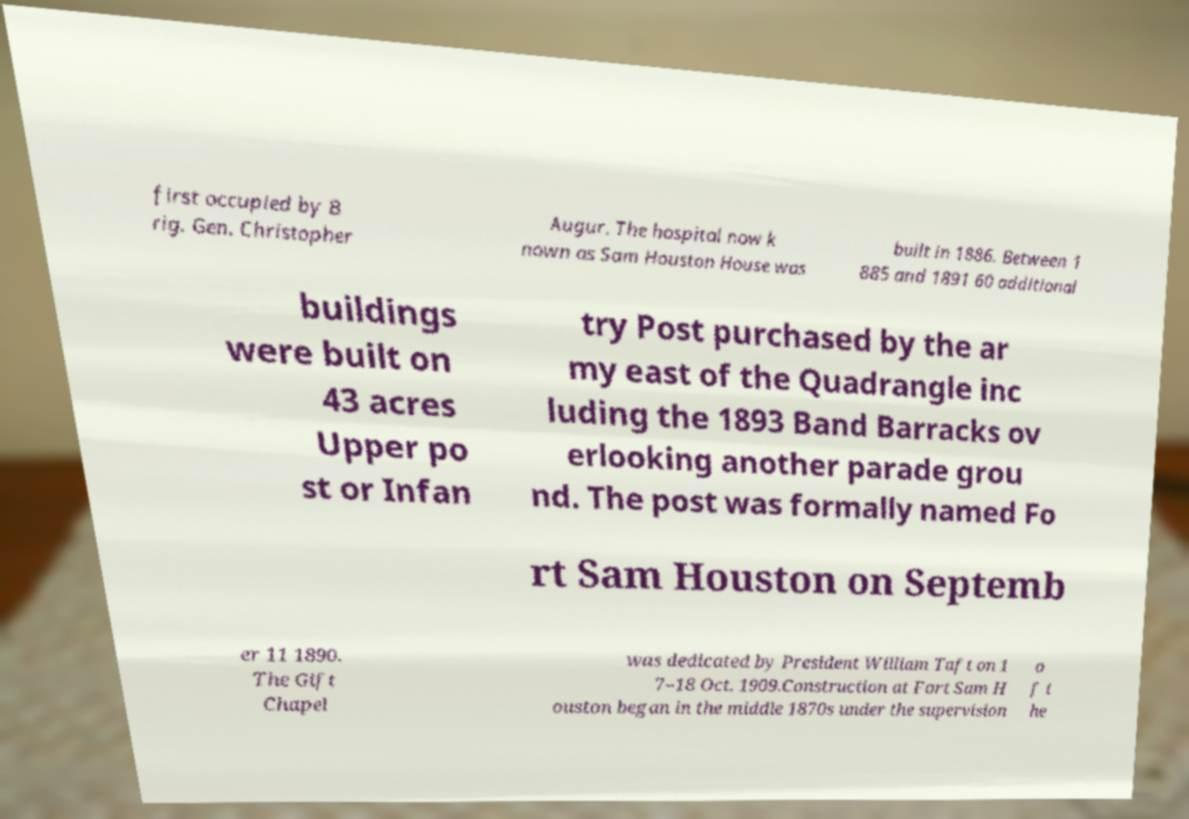I need the written content from this picture converted into text. Can you do that? first occupied by B rig. Gen. Christopher Augur. The hospital now k nown as Sam Houston House was built in 1886. Between 1 885 and 1891 60 additional buildings were built on 43 acres Upper po st or Infan try Post purchased by the ar my east of the Quadrangle inc luding the 1893 Band Barracks ov erlooking another parade grou nd. The post was formally named Fo rt Sam Houston on Septemb er 11 1890. The Gift Chapel was dedicated by President William Taft on 1 7–18 Oct. 1909.Construction at Fort Sam H ouston began in the middle 1870s under the supervision o f t he 